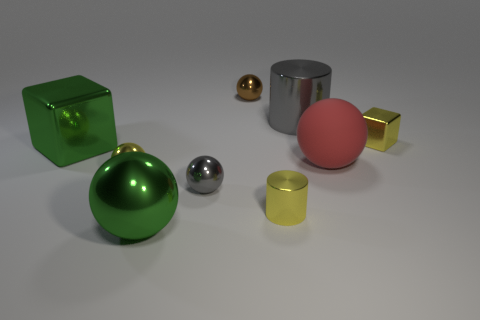What is the size of the yellow sphere that is made of the same material as the green sphere?
Offer a very short reply. Small. What number of tiny brown shiny objects have the same shape as the big matte object?
Make the answer very short. 1. There is a metal sphere behind the yellow thing to the left of the tiny brown object; what is its size?
Keep it short and to the point. Small. There is a red object that is the same size as the gray cylinder; what material is it?
Provide a succinct answer. Rubber. Are there any tiny yellow cubes that have the same material as the tiny gray sphere?
Ensure brevity in your answer.  Yes. There is a shiny cylinder that is in front of the green metallic block that is on the left side of the gray metal object behind the big green shiny cube; what color is it?
Your response must be concise. Yellow. There is a thing right of the matte sphere; is its color the same as the metal cylinder that is in front of the yellow ball?
Ensure brevity in your answer.  Yes. Is there anything else that has the same color as the rubber thing?
Offer a terse response. No. Is the number of tiny gray metallic balls in front of the big green block less than the number of big green objects?
Offer a terse response. Yes. What number of large green cylinders are there?
Your response must be concise. 0. 